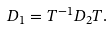Convert formula to latex. <formula><loc_0><loc_0><loc_500><loc_500>D _ { 1 } = T ^ { - 1 } D _ { 2 } T .</formula> 